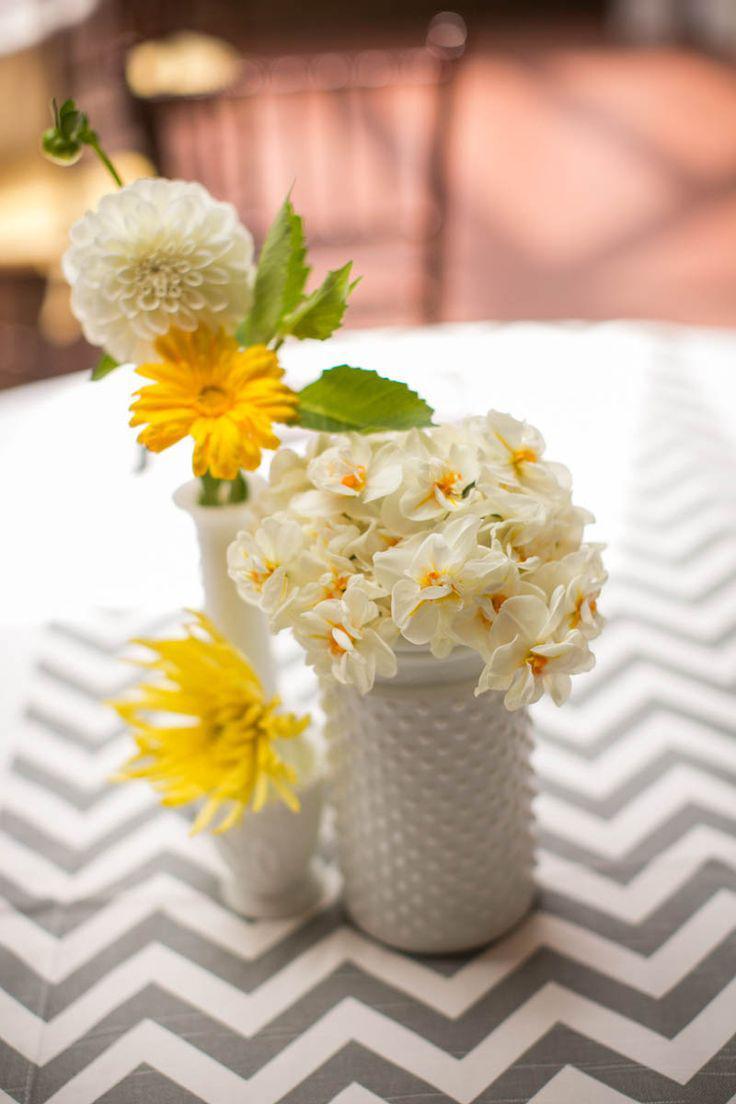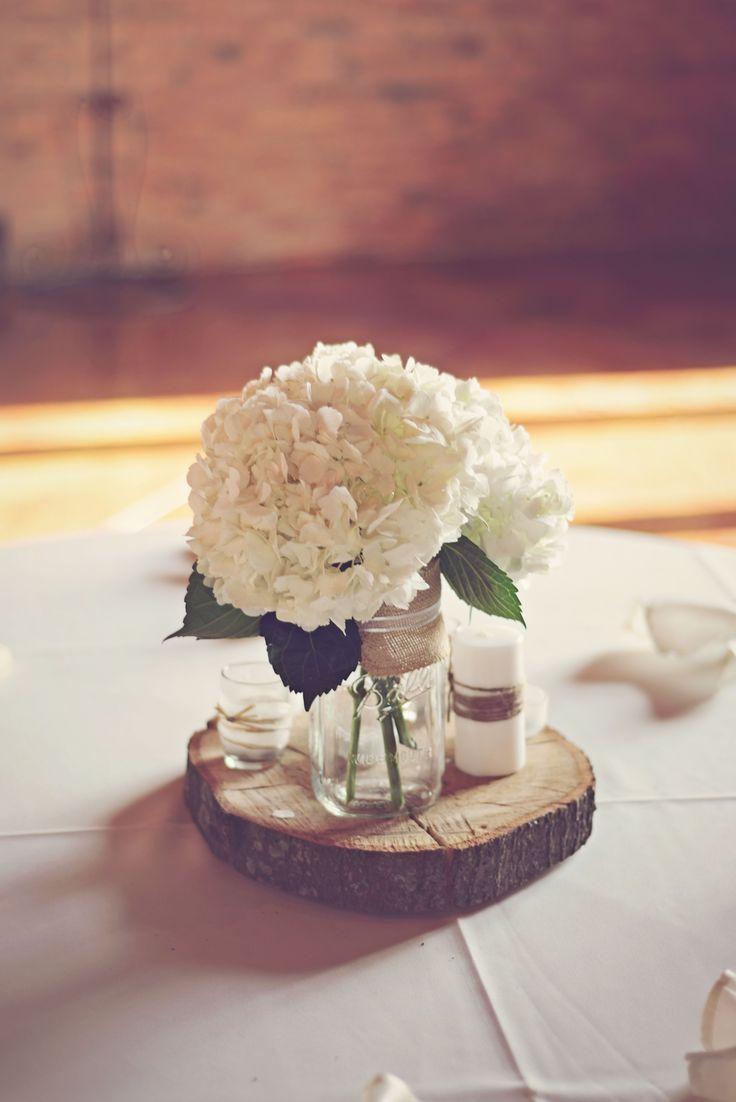The first image is the image on the left, the second image is the image on the right. For the images shown, is this caption "There are 3 non-clear vases." true? Answer yes or no. Yes. 